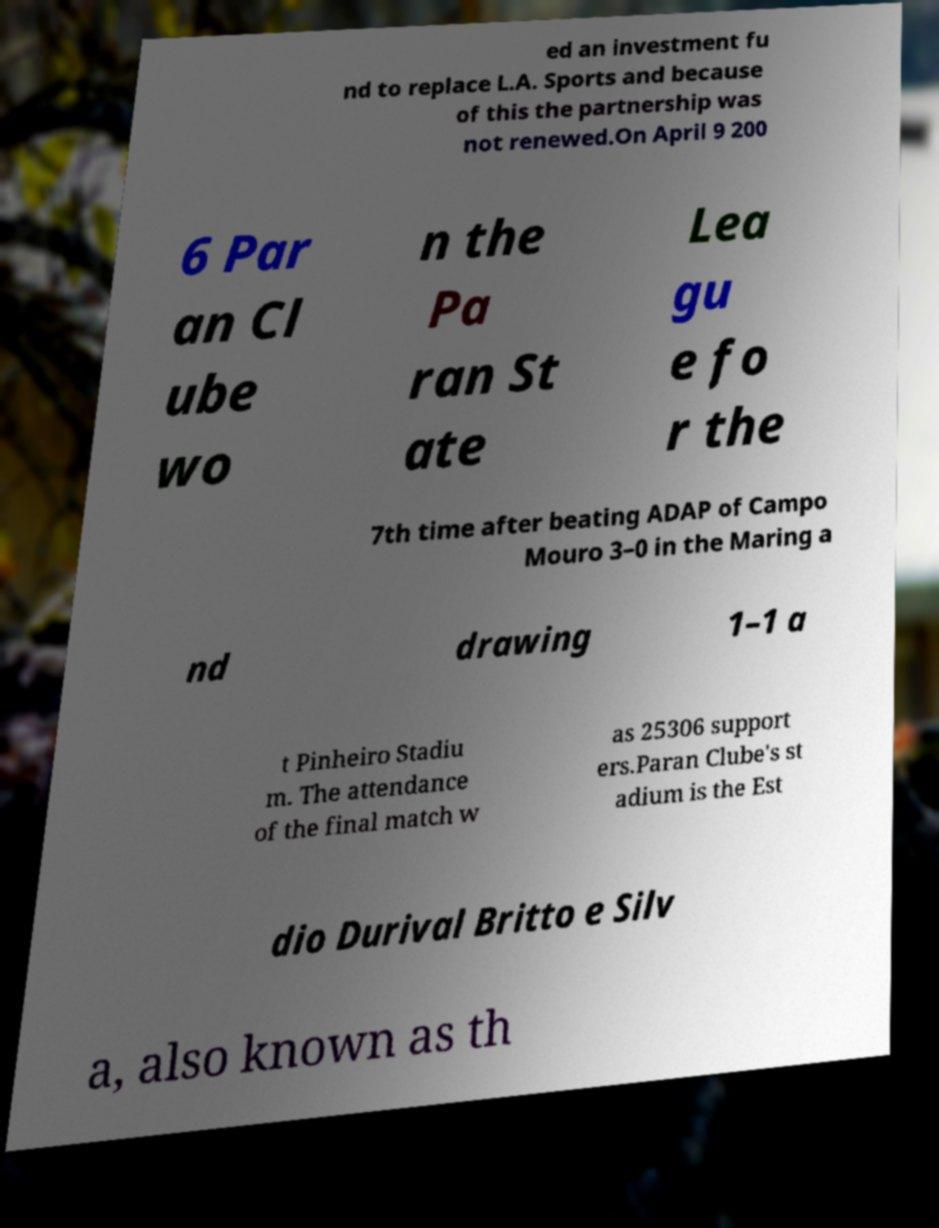For documentation purposes, I need the text within this image transcribed. Could you provide that? ed an investment fu nd to replace L.A. Sports and because of this the partnership was not renewed.On April 9 200 6 Par an Cl ube wo n the Pa ran St ate Lea gu e fo r the 7th time after beating ADAP of Campo Mouro 3–0 in the Maring a nd drawing 1–1 a t Pinheiro Stadiu m. The attendance of the final match w as 25306 support ers.Paran Clube's st adium is the Est dio Durival Britto e Silv a, also known as th 